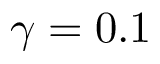Convert formula to latex. <formula><loc_0><loc_0><loc_500><loc_500>\gamma = 0 . 1</formula> 